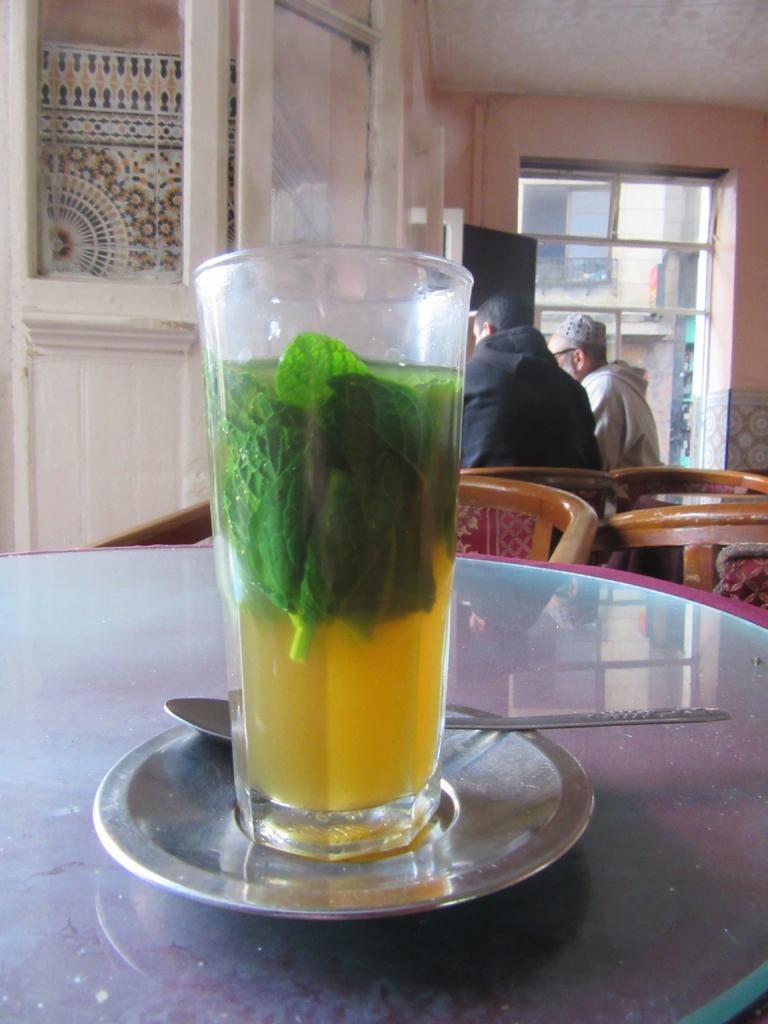Please provide a concise description of this image. In the image in the center, we can see one table. On the table, there is a saucer, spoon and glass. In the glass, we can see mint leaves and water. In the background there is a wall, roof, window, chairs and two persons are sitting. 